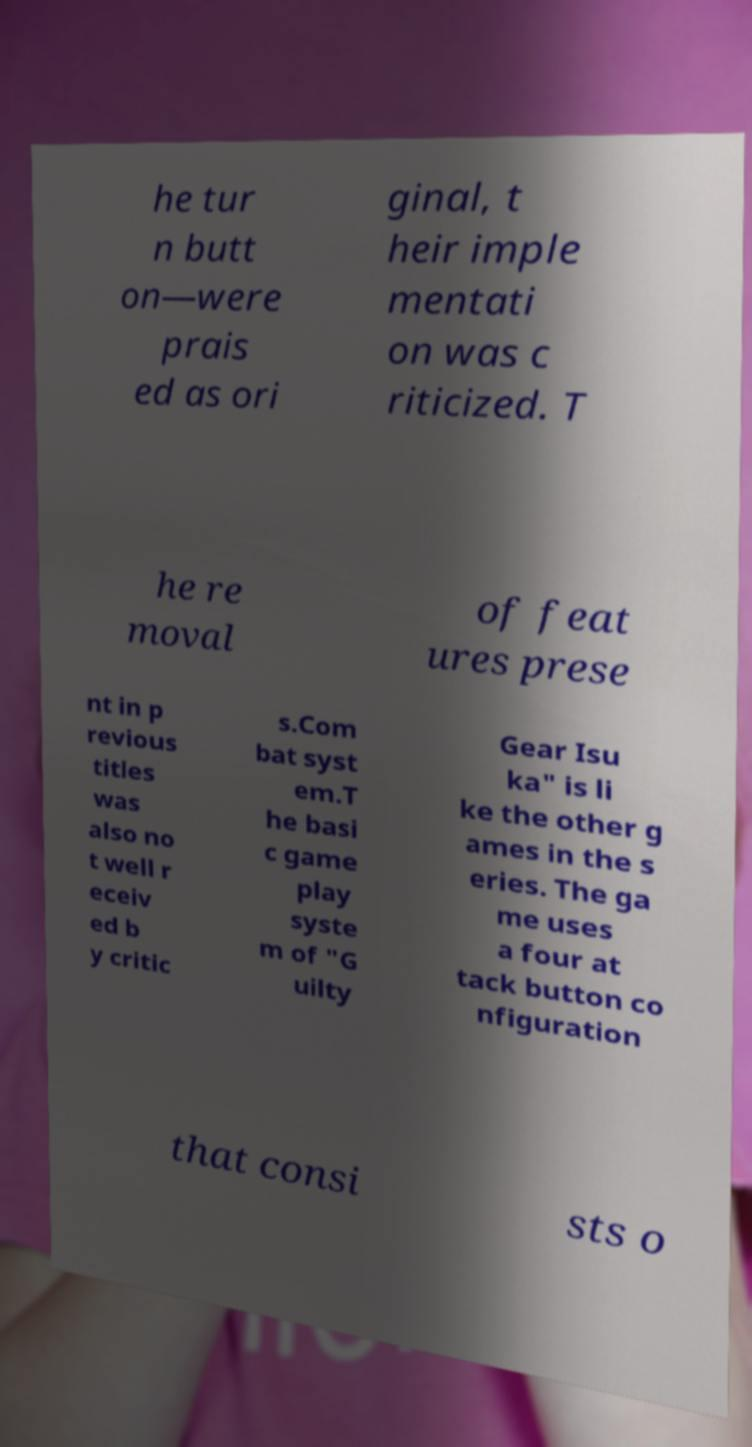Can you accurately transcribe the text from the provided image for me? he tur n butt on—were prais ed as ori ginal, t heir imple mentati on was c riticized. T he re moval of feat ures prese nt in p revious titles was also no t well r eceiv ed b y critic s.Com bat syst em.T he basi c game play syste m of "G uilty Gear Isu ka" is li ke the other g ames in the s eries. The ga me uses a four at tack button co nfiguration that consi sts o 